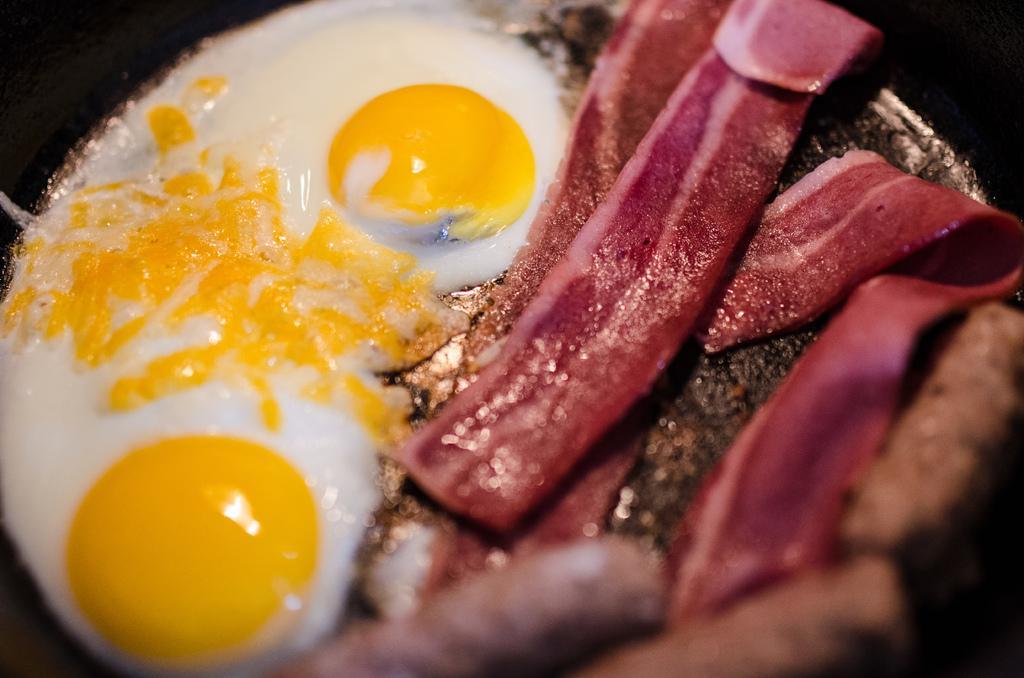Can you describe this image briefly? In this image I can see the black colored bowl and in the bowl I can see a food item which is brown, red, cream, white and yellow in color. 